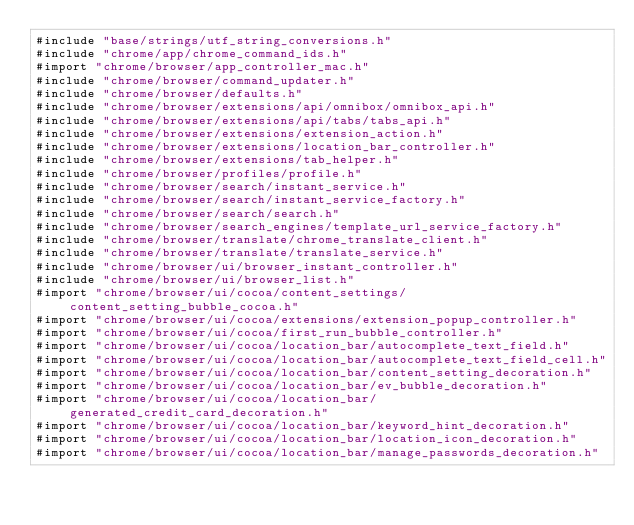Convert code to text. <code><loc_0><loc_0><loc_500><loc_500><_ObjectiveC_>#include "base/strings/utf_string_conversions.h"
#include "chrome/app/chrome_command_ids.h"
#import "chrome/browser/app_controller_mac.h"
#include "chrome/browser/command_updater.h"
#include "chrome/browser/defaults.h"
#include "chrome/browser/extensions/api/omnibox/omnibox_api.h"
#include "chrome/browser/extensions/api/tabs/tabs_api.h"
#include "chrome/browser/extensions/extension_action.h"
#include "chrome/browser/extensions/location_bar_controller.h"
#include "chrome/browser/extensions/tab_helper.h"
#include "chrome/browser/profiles/profile.h"
#include "chrome/browser/search/instant_service.h"
#include "chrome/browser/search/instant_service_factory.h"
#include "chrome/browser/search/search.h"
#include "chrome/browser/search_engines/template_url_service_factory.h"
#include "chrome/browser/translate/chrome_translate_client.h"
#include "chrome/browser/translate/translate_service.h"
#include "chrome/browser/ui/browser_instant_controller.h"
#include "chrome/browser/ui/browser_list.h"
#import "chrome/browser/ui/cocoa/content_settings/content_setting_bubble_cocoa.h"
#import "chrome/browser/ui/cocoa/extensions/extension_popup_controller.h"
#import "chrome/browser/ui/cocoa/first_run_bubble_controller.h"
#import "chrome/browser/ui/cocoa/location_bar/autocomplete_text_field.h"
#import "chrome/browser/ui/cocoa/location_bar/autocomplete_text_field_cell.h"
#import "chrome/browser/ui/cocoa/location_bar/content_setting_decoration.h"
#import "chrome/browser/ui/cocoa/location_bar/ev_bubble_decoration.h"
#import "chrome/browser/ui/cocoa/location_bar/generated_credit_card_decoration.h"
#import "chrome/browser/ui/cocoa/location_bar/keyword_hint_decoration.h"
#import "chrome/browser/ui/cocoa/location_bar/location_icon_decoration.h"
#import "chrome/browser/ui/cocoa/location_bar/manage_passwords_decoration.h"</code> 